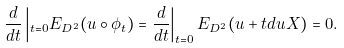Convert formula to latex. <formula><loc_0><loc_0><loc_500><loc_500>\frac { d } { d t } \left | _ { t = 0 } E _ { D ^ { 2 } } ( u \circ \phi _ { t } ) = \frac { d } { d t } \right | _ { t = 0 } E _ { D ^ { 2 } } ( u + t d u X ) = 0 .</formula> 